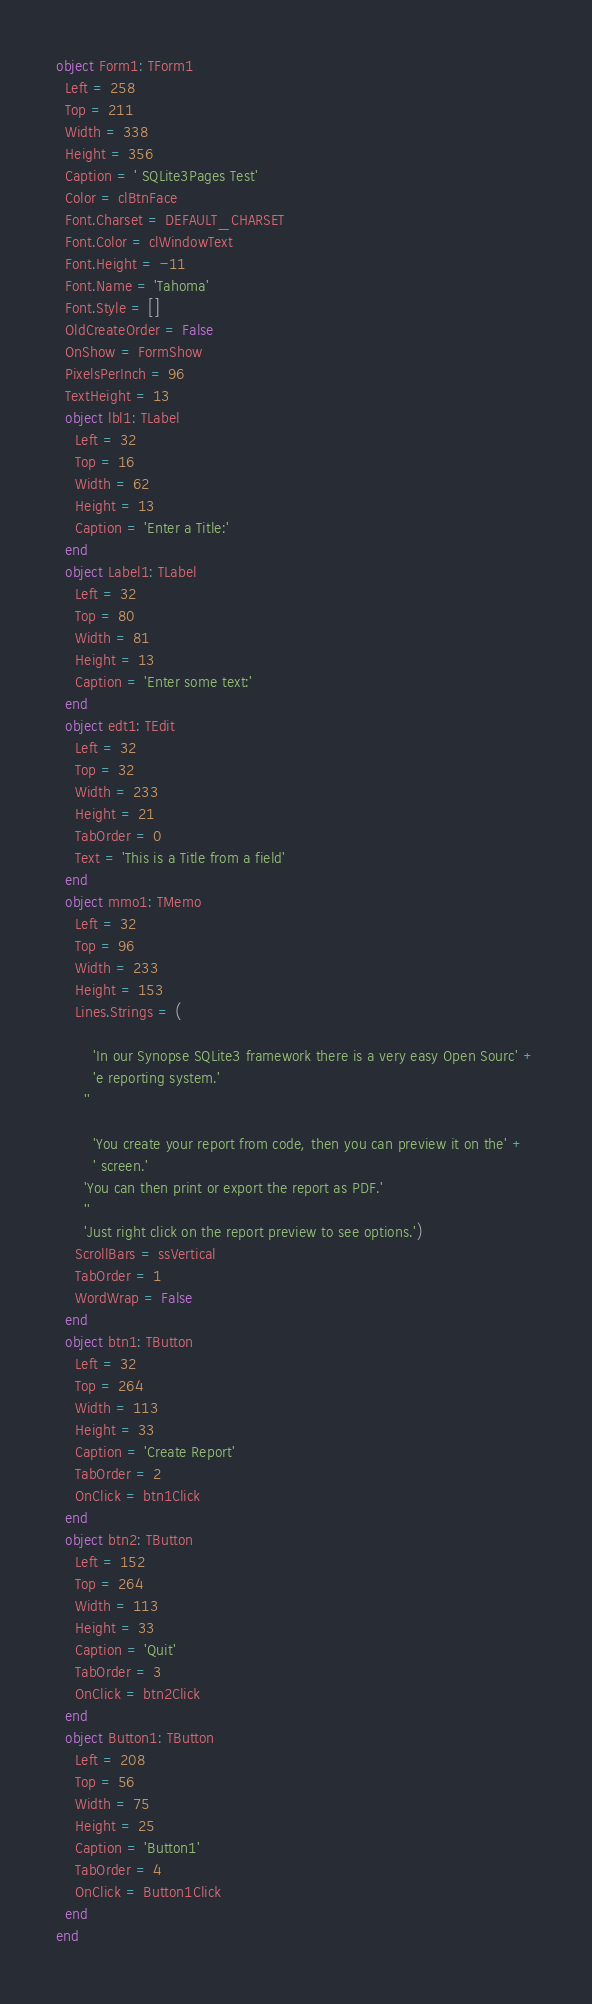<code> <loc_0><loc_0><loc_500><loc_500><_Pascal_>object Form1: TForm1
  Left = 258
  Top = 211
  Width = 338
  Height = 356
  Caption = ' SQLite3Pages Test'
  Color = clBtnFace
  Font.Charset = DEFAULT_CHARSET
  Font.Color = clWindowText
  Font.Height = -11
  Font.Name = 'Tahoma'
  Font.Style = []
  OldCreateOrder = False
  OnShow = FormShow
  PixelsPerInch = 96
  TextHeight = 13
  object lbl1: TLabel
    Left = 32
    Top = 16
    Width = 62
    Height = 13
    Caption = 'Enter a Title:'
  end
  object Label1: TLabel
    Left = 32
    Top = 80
    Width = 81
    Height = 13
    Caption = 'Enter some text:'
  end
  object edt1: TEdit
    Left = 32
    Top = 32
    Width = 233
    Height = 21
    TabOrder = 0
    Text = 'This is a Title from a field'
  end
  object mmo1: TMemo
    Left = 32
    Top = 96
    Width = 233
    Height = 153
    Lines.Strings = (
      
        'In our Synopse SQLite3 framework there is a very easy Open Sourc' +
        'e reporting system.'
      ''
      
        'You create your report from code, then you can preview it on the' +
        ' screen.'
      'You can then print or export the report as PDF.'
      ''
      'Just right click on the report preview to see options.')
    ScrollBars = ssVertical
    TabOrder = 1
    WordWrap = False
  end
  object btn1: TButton
    Left = 32
    Top = 264
    Width = 113
    Height = 33
    Caption = 'Create Report'
    TabOrder = 2
    OnClick = btn1Click
  end
  object btn2: TButton
    Left = 152
    Top = 264
    Width = 113
    Height = 33
    Caption = 'Quit'
    TabOrder = 3
    OnClick = btn2Click
  end
  object Button1: TButton
    Left = 208
    Top = 56
    Width = 75
    Height = 25
    Caption = 'Button1'
    TabOrder = 4
    OnClick = Button1Click
  end
end
</code> 